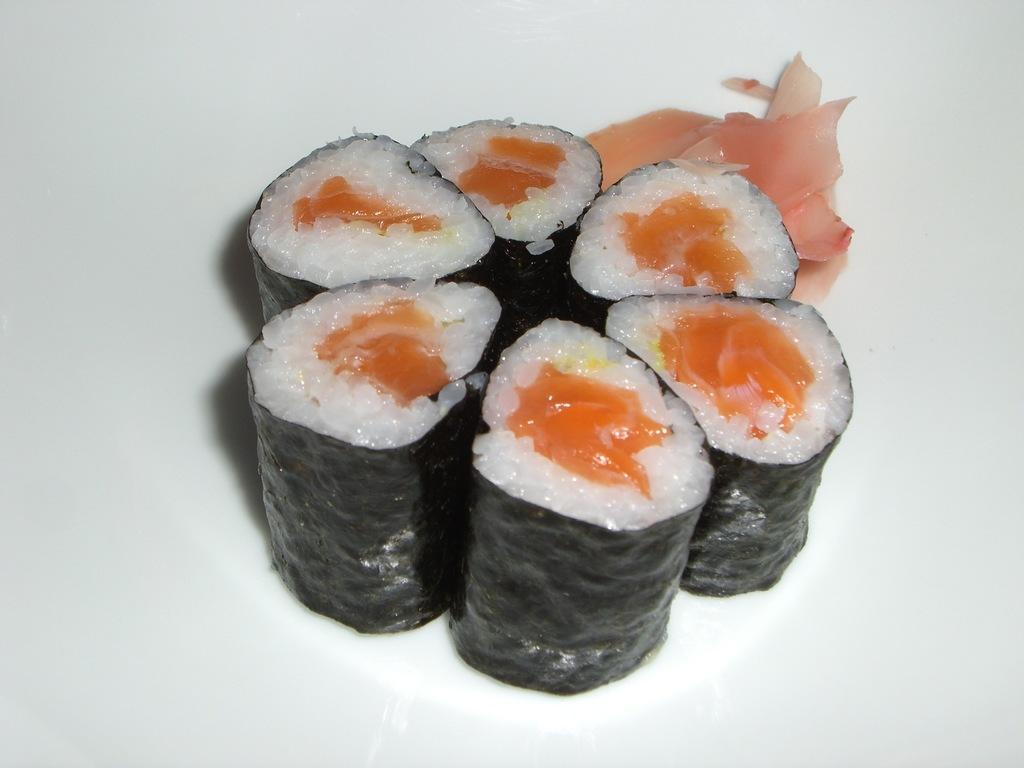Can you describe this image briefly? In this picture we can see sushi kept on a white plate. It is stuffed with rice and meat. 